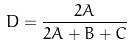<formula> <loc_0><loc_0><loc_500><loc_500>D = \frac { 2 A } { 2 A + B + C }</formula> 